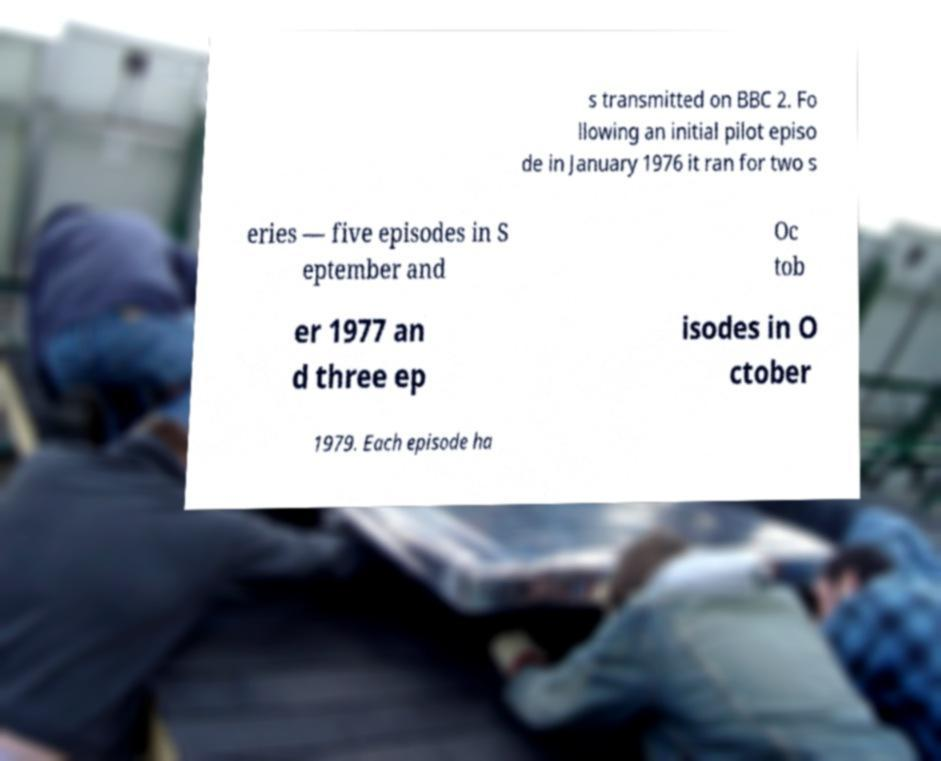For documentation purposes, I need the text within this image transcribed. Could you provide that? s transmitted on BBC 2. Fo llowing an initial pilot episo de in January 1976 it ran for two s eries — five episodes in S eptember and Oc tob er 1977 an d three ep isodes in O ctober 1979. Each episode ha 